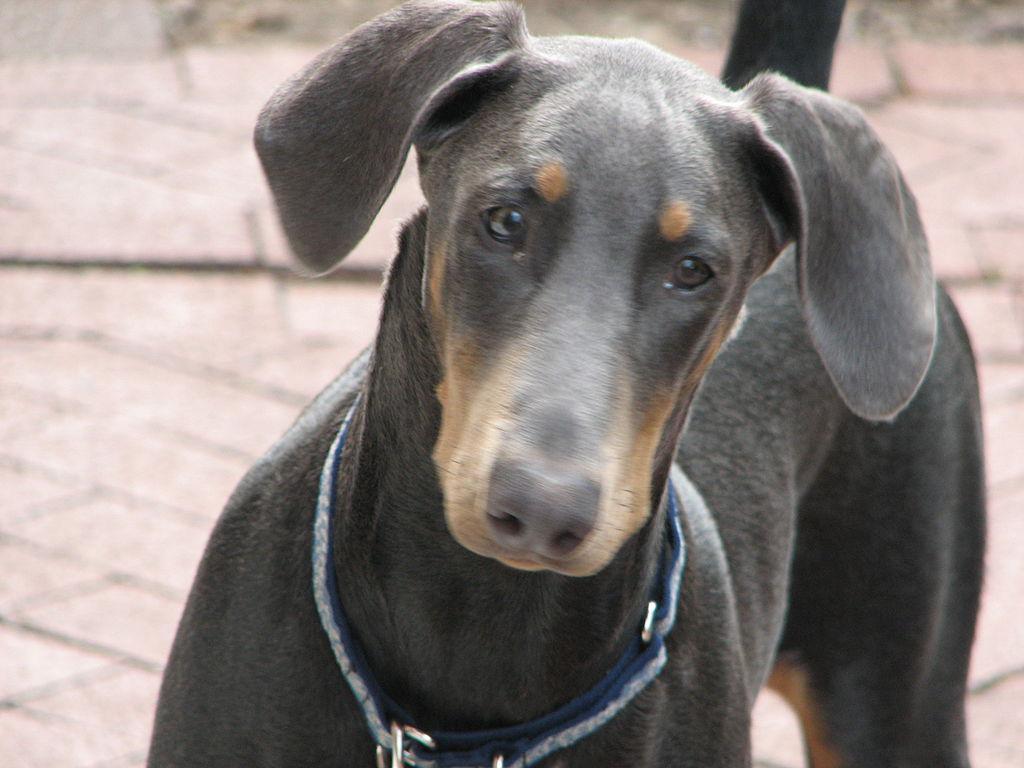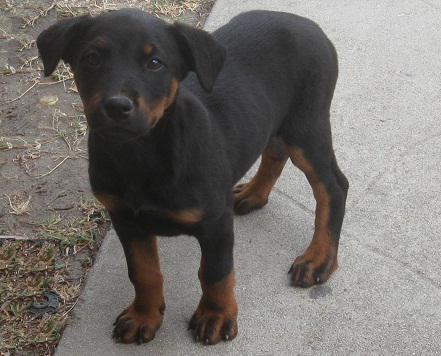The first image is the image on the left, the second image is the image on the right. For the images shown, is this caption "A dog's full face is visible." true? Answer yes or no. Yes. The first image is the image on the left, the second image is the image on the right. Assess this claim about the two images: "Each image shows a dog standing in profile, and the dogs in the left and right images have their bodies turned toward each other.". Correct or not? Answer yes or no. No. 